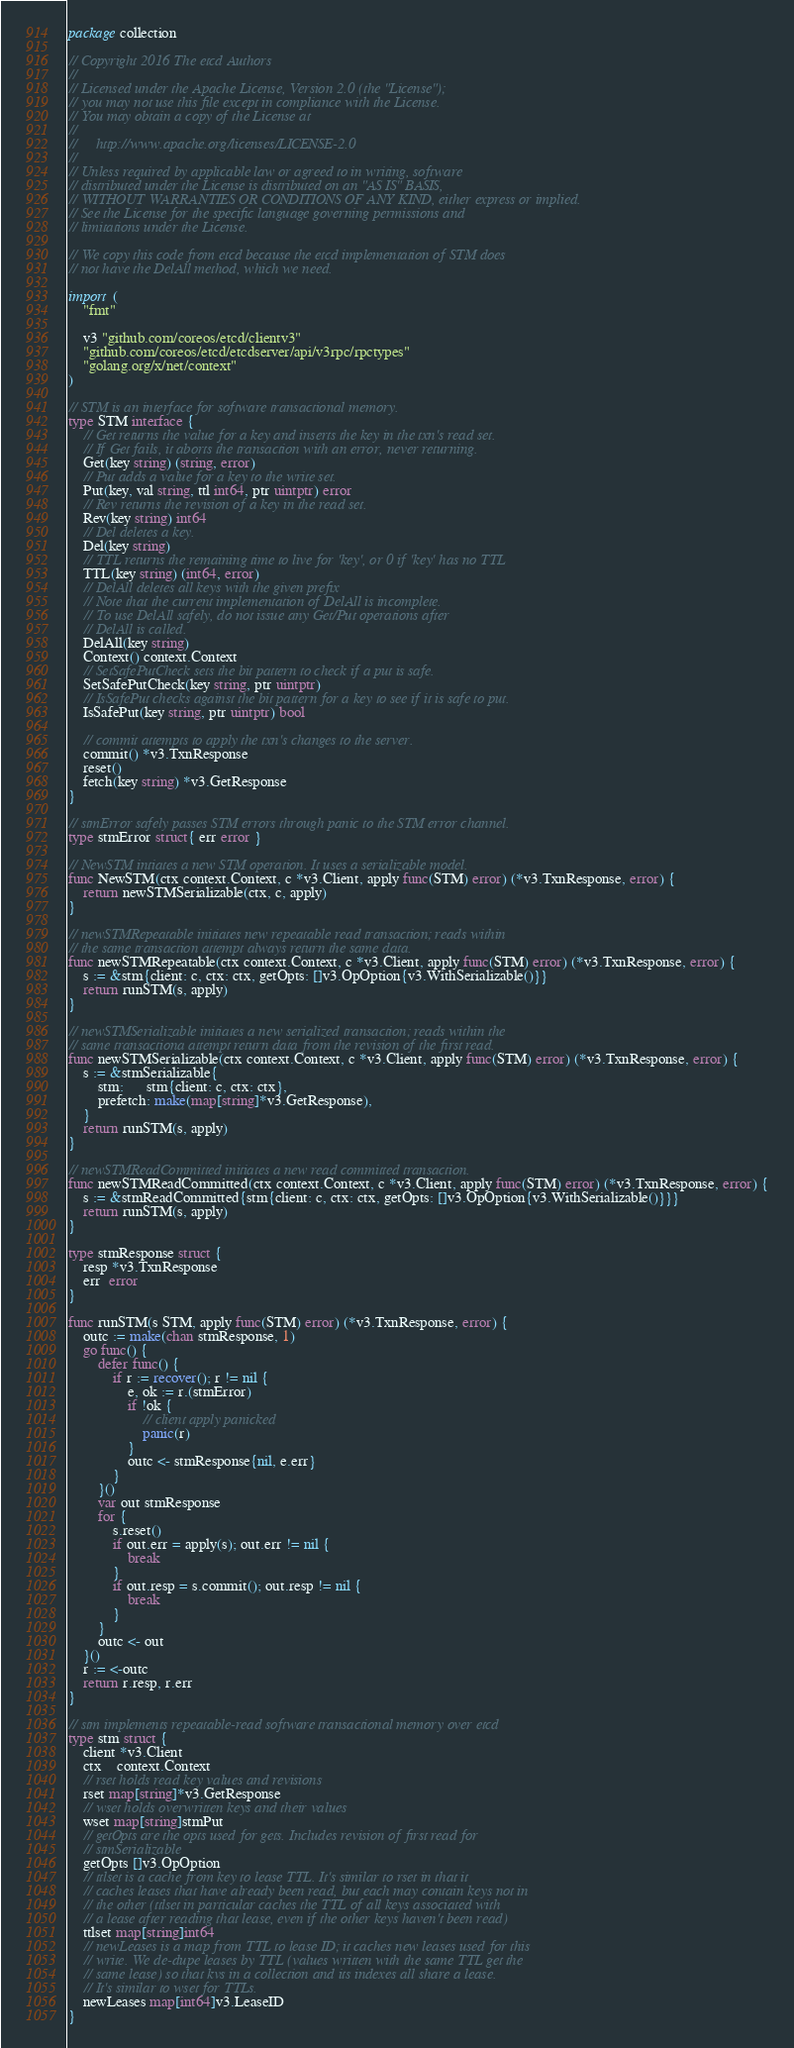Convert code to text. <code><loc_0><loc_0><loc_500><loc_500><_Go_>package collection

// Copyright 2016 The etcd Authors
//
// Licensed under the Apache License, Version 2.0 (the "License");
// you may not use this file except in compliance with the License.
// You may obtain a copy of the License at
//
//     http://www.apache.org/licenses/LICENSE-2.0
//
// Unless required by applicable law or agreed to in writing, software
// distributed under the License is distributed on an "AS IS" BASIS,
// WITHOUT WARRANTIES OR CONDITIONS OF ANY KIND, either express or implied.
// See the License for the specific language governing permissions and
// limitations under the License.

// We copy this code from etcd because the etcd implementation of STM does
// not have the DelAll method, which we need.

import (
	"fmt"

	v3 "github.com/coreos/etcd/clientv3"
	"github.com/coreos/etcd/etcdserver/api/v3rpc/rpctypes"
	"golang.org/x/net/context"
)

// STM is an interface for software transactional memory.
type STM interface {
	// Get returns the value for a key and inserts the key in the txn's read set.
	// If Get fails, it aborts the transaction with an error, never returning.
	Get(key string) (string, error)
	// Put adds a value for a key to the write set.
	Put(key, val string, ttl int64, ptr uintptr) error
	// Rev returns the revision of a key in the read set.
	Rev(key string) int64
	// Del deletes a key.
	Del(key string)
	// TTL returns the remaining time to live for 'key', or 0 if 'key' has no TTL
	TTL(key string) (int64, error)
	// DelAll deletes all keys with the given prefix
	// Note that the current implementation of DelAll is incomplete.
	// To use DelAll safely, do not issue any Get/Put operations after
	// DelAll is called.
	DelAll(key string)
	Context() context.Context
	// SetSafePutCheck sets the bit pattern to check if a put is safe.
	SetSafePutCheck(key string, ptr uintptr)
	// IsSafePut checks against the bit pattern for a key to see if it is safe to put.
	IsSafePut(key string, ptr uintptr) bool

	// commit attempts to apply the txn's changes to the server.
	commit() *v3.TxnResponse
	reset()
	fetch(key string) *v3.GetResponse
}

// stmError safely passes STM errors through panic to the STM error channel.
type stmError struct{ err error }

// NewSTM intiates a new STM operation. It uses a serializable model.
func NewSTM(ctx context.Context, c *v3.Client, apply func(STM) error) (*v3.TxnResponse, error) {
	return newSTMSerializable(ctx, c, apply)
}

// newSTMRepeatable initiates new repeatable read transaction; reads within
// the same transaction attempt always return the same data.
func newSTMRepeatable(ctx context.Context, c *v3.Client, apply func(STM) error) (*v3.TxnResponse, error) {
	s := &stm{client: c, ctx: ctx, getOpts: []v3.OpOption{v3.WithSerializable()}}
	return runSTM(s, apply)
}

// newSTMSerializable initiates a new serialized transaction; reads within the
// same transactiona attempt return data from the revision of the first read.
func newSTMSerializable(ctx context.Context, c *v3.Client, apply func(STM) error) (*v3.TxnResponse, error) {
	s := &stmSerializable{
		stm:      stm{client: c, ctx: ctx},
		prefetch: make(map[string]*v3.GetResponse),
	}
	return runSTM(s, apply)
}

// newSTMReadCommitted initiates a new read committed transaction.
func newSTMReadCommitted(ctx context.Context, c *v3.Client, apply func(STM) error) (*v3.TxnResponse, error) {
	s := &stmReadCommitted{stm{client: c, ctx: ctx, getOpts: []v3.OpOption{v3.WithSerializable()}}}
	return runSTM(s, apply)
}

type stmResponse struct {
	resp *v3.TxnResponse
	err  error
}

func runSTM(s STM, apply func(STM) error) (*v3.TxnResponse, error) {
	outc := make(chan stmResponse, 1)
	go func() {
		defer func() {
			if r := recover(); r != nil {
				e, ok := r.(stmError)
				if !ok {
					// client apply panicked
					panic(r)
				}
				outc <- stmResponse{nil, e.err}
			}
		}()
		var out stmResponse
		for {
			s.reset()
			if out.err = apply(s); out.err != nil {
				break
			}
			if out.resp = s.commit(); out.resp != nil {
				break
			}
		}
		outc <- out
	}()
	r := <-outc
	return r.resp, r.err
}

// stm implements repeatable-read software transactional memory over etcd
type stm struct {
	client *v3.Client
	ctx    context.Context
	// rset holds read key values and revisions
	rset map[string]*v3.GetResponse
	// wset holds overwritten keys and their values
	wset map[string]stmPut
	// getOpts are the opts used for gets. Includes revision of first read for
	// stmSerializable
	getOpts []v3.OpOption
	// ttlset is a cache from key to lease TTL. It's similar to rset in that it
	// caches leases that have already been read, but each may contain keys not in
	// the other (ttlset in particular caches the TTL of all keys associated with
	// a lease after reading that lease, even if the other keys haven't been read)
	ttlset map[string]int64
	// newLeases is a map from TTL to lease ID; it caches new leases used for this
	// write. We de-dupe leases by TTL (values written with the same TTL get the
	// same lease) so that kvs in a collection and its indexes all share a lease.
	// It's similar to wset for TTLs.
	newLeases map[int64]v3.LeaseID
}
</code> 